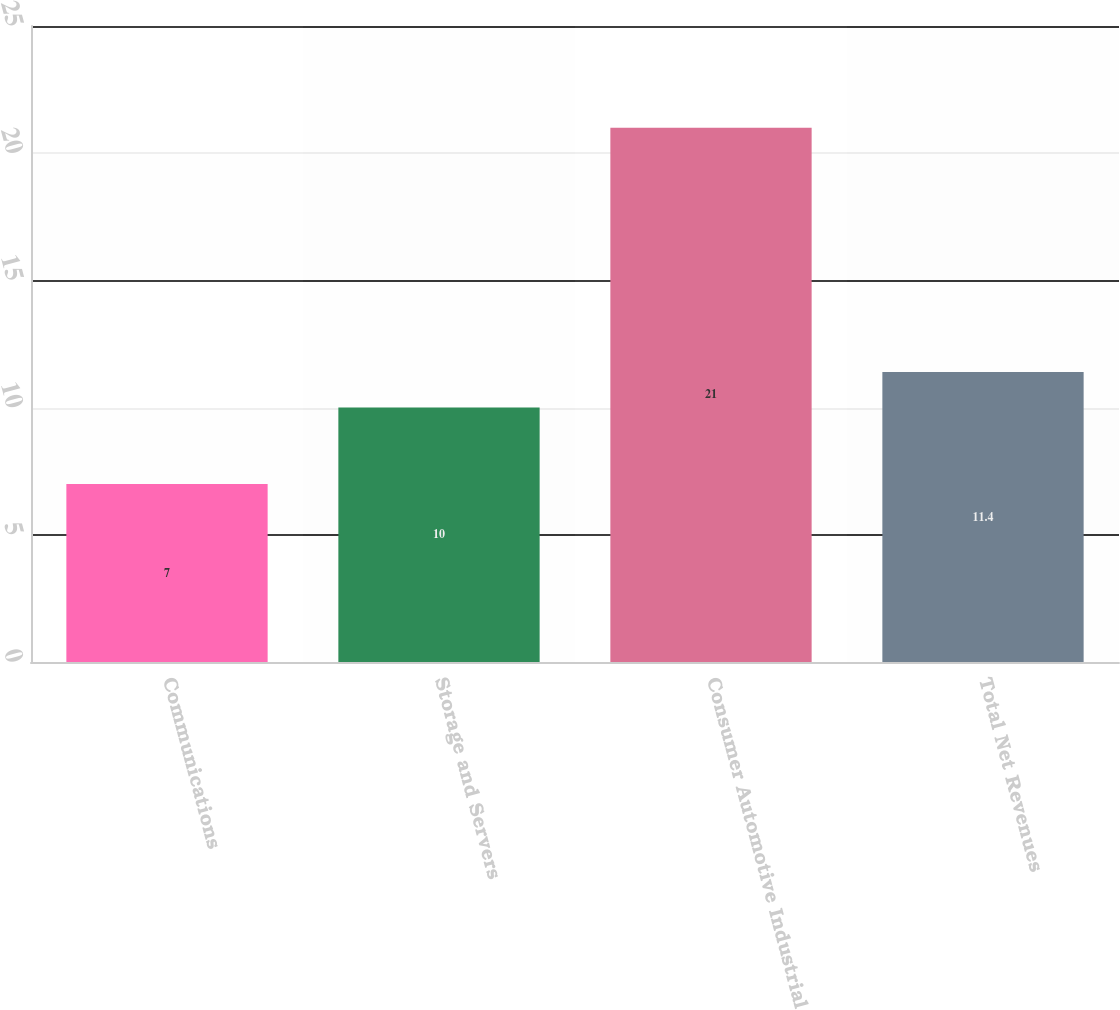<chart> <loc_0><loc_0><loc_500><loc_500><bar_chart><fcel>Communications<fcel>Storage and Servers<fcel>Consumer Automotive Industrial<fcel>Total Net Revenues<nl><fcel>7<fcel>10<fcel>21<fcel>11.4<nl></chart> 